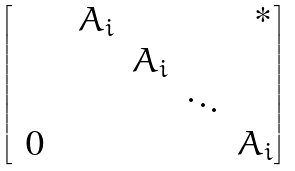<formula> <loc_0><loc_0><loc_500><loc_500>\begin{bmatrix} & & A _ { i } & & & \text { *} \\ & & & A _ { i } & & \\ & & & & \ddots & \\ \text { 0} & & & & & A _ { i } \end{bmatrix}</formula> 